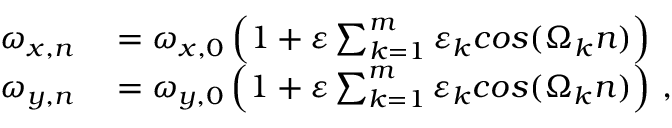Convert formula to latex. <formula><loc_0><loc_0><loc_500><loc_500>\begin{array} { r l } { \omega _ { x , n } } & = \omega _ { x , 0 } \left ( 1 + \varepsilon \sum _ { k = 1 } ^ { m } \varepsilon _ { k } \cos ( \Omega _ { k } n ) \right ) } \\ { \omega _ { y , n } } & = \omega _ { y , 0 } \left ( 1 + \varepsilon \sum _ { k = 1 } ^ { m } \varepsilon _ { k } \cos ( \Omega _ { k } n ) \right ) \, , } \end{array}</formula> 